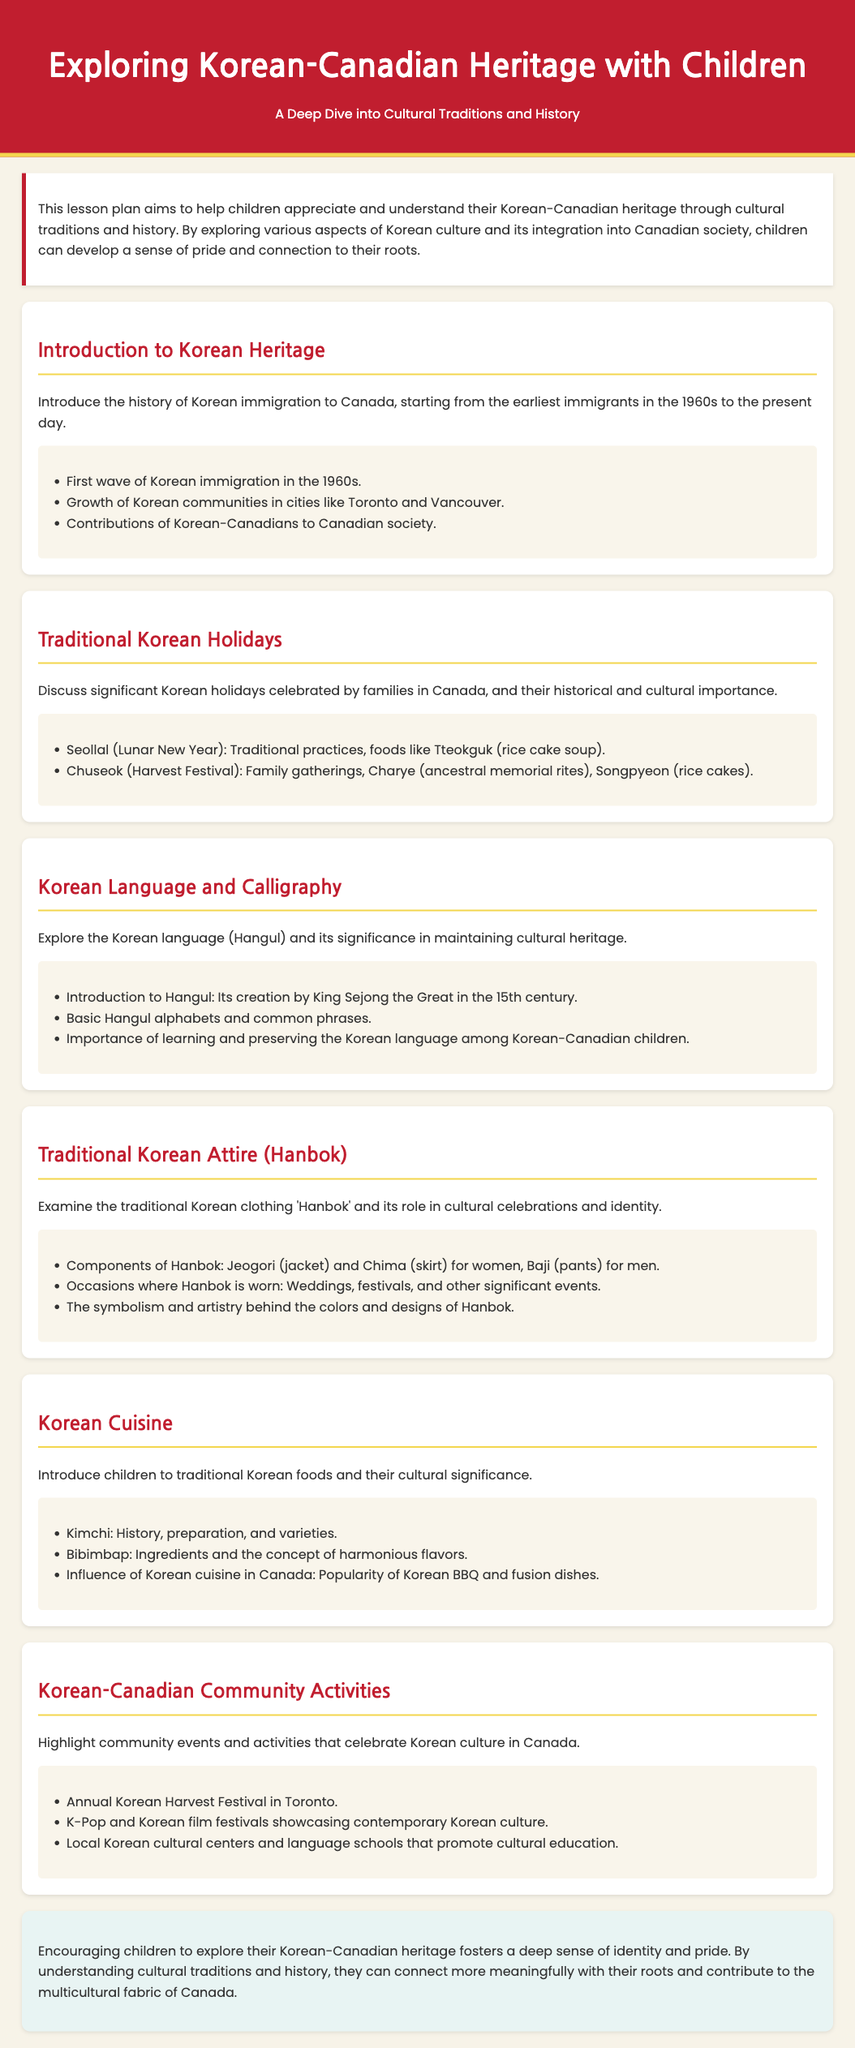What is the first wave of Korean immigration to Canada? The lesson plan states that the first wave of Korean immigration started in the 1960s.
Answer: 1960s What is Seollal? Seollal is mentioned as the Lunar New Year, a significant holiday with traditional practices and foods like Tteokguk.
Answer: Lunar New Year Who created Hangul? The document notes that Hangul was created by King Sejong the Great in the 15th century.
Answer: King Sejong the Great What is a key component of Hanbok for women? The key component for women’s Hanbok mentioned is the Jeogori, which is the jacket.
Answer: Jeogori What dish is known for its harmonious flavors? The document highlights Bibimbap as a dish that embodies the concept of harmonious flavors.
Answer: Bibimbap What community event is held annually in Toronto? The lesson plan mentions the Annual Korean Harvest Festival as a community event celebrated in Toronto.
Answer: Annual Korean Harvest Festival What is a popular Korean food mentioned in the document? Kimchi is listed as a traditional Korean food discussed in the lesson plan.
Answer: Kimchi What is emphasized as important for Korean-Canadian children? The document emphasizes the importance of learning and preserving the Korean language among Korean-Canadian children.
Answer: Learning and preserving the Korean language What is the main aim of this lesson plan? The main aim is to help children appreciate and understand their Korean-Canadian heritage.
Answer: Help children appreciate and understand their Korean-Canadian heritage 